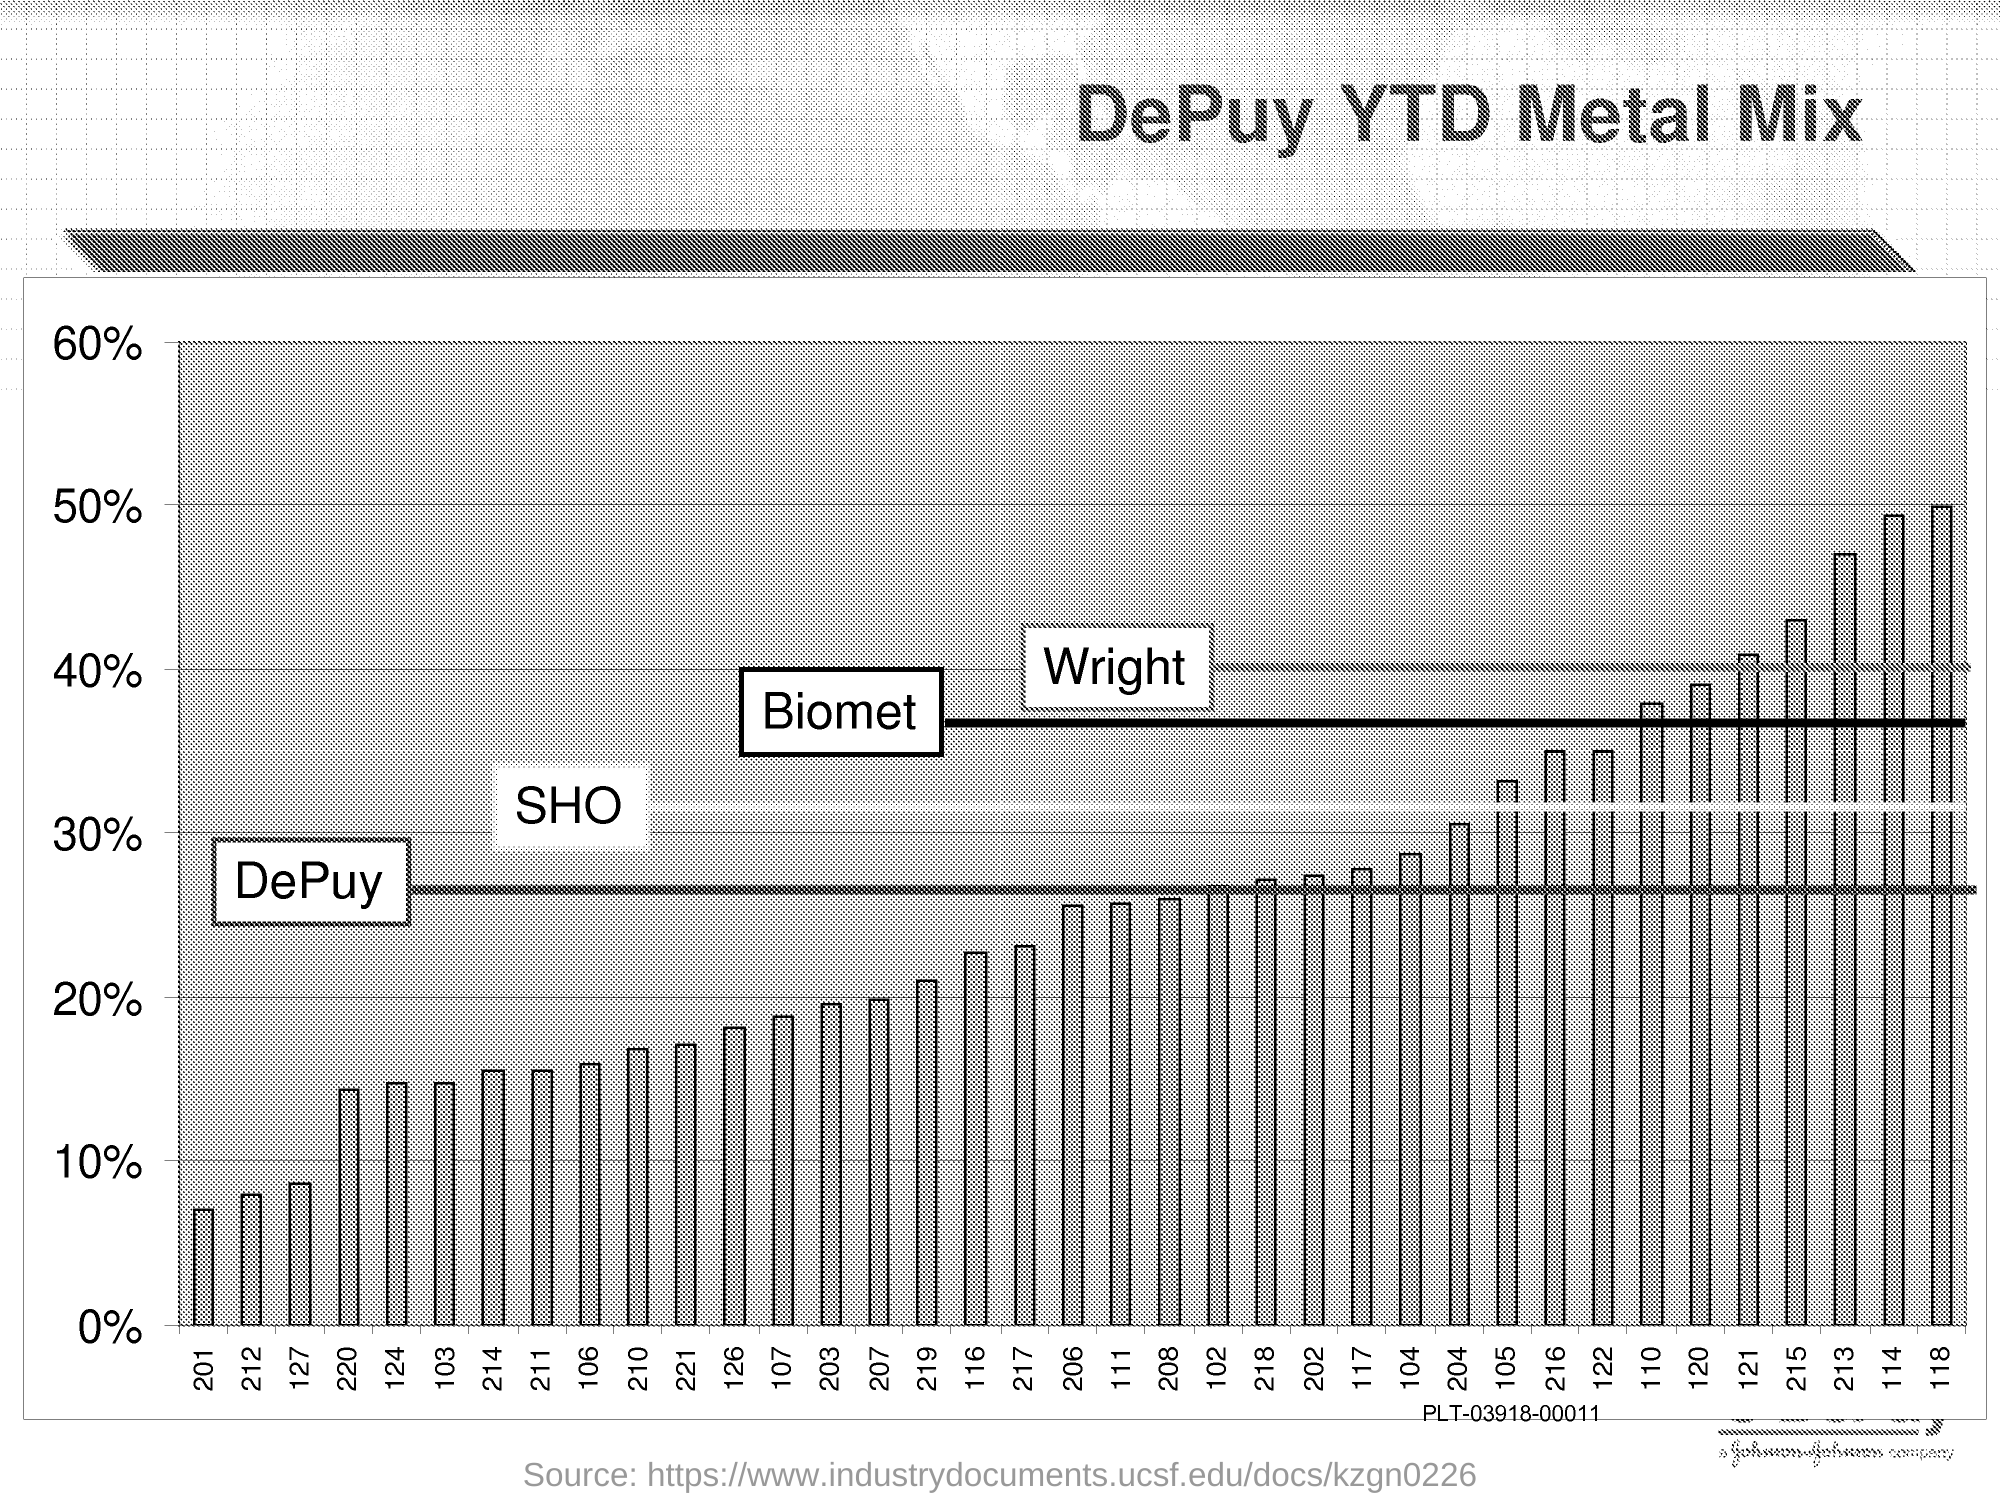What is the title of this graph?
Offer a terse response. DePuy YTD Metal Mix. 